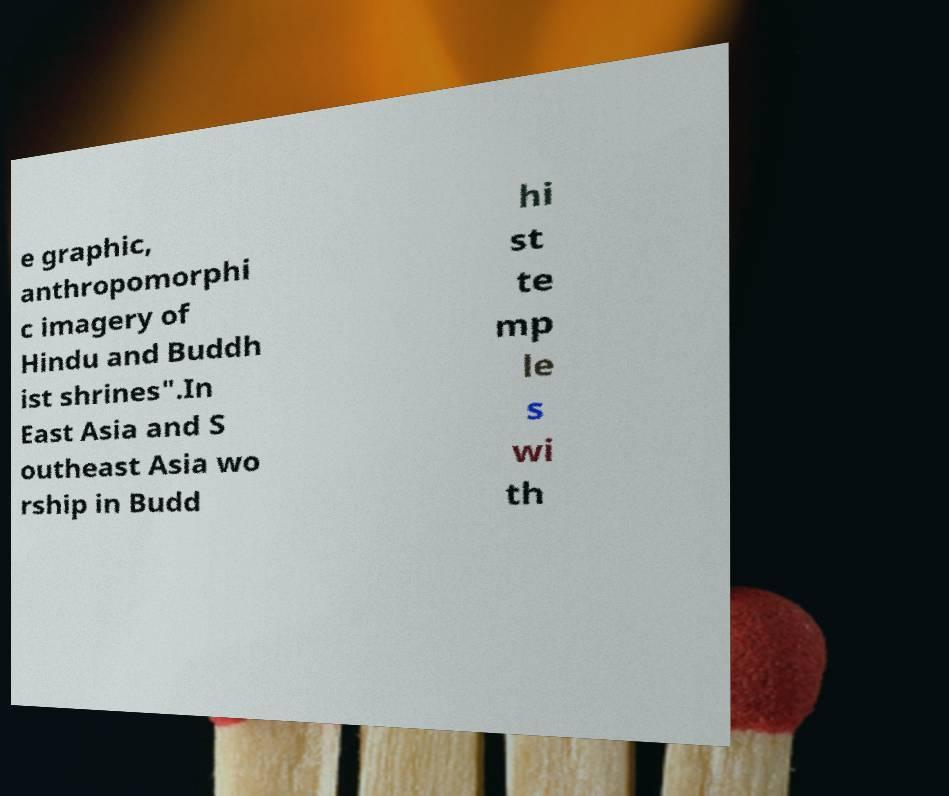What messages or text are displayed in this image? I need them in a readable, typed format. e graphic, anthropomorphi c imagery of Hindu and Buddh ist shrines".In East Asia and S outheast Asia wo rship in Budd hi st te mp le s wi th 